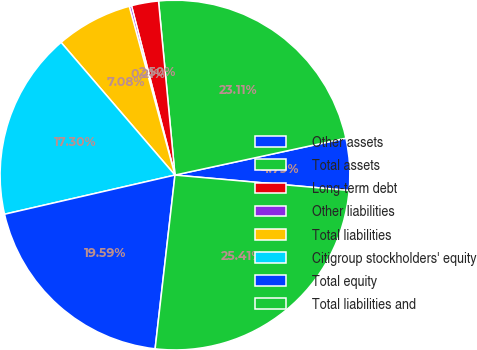<chart> <loc_0><loc_0><loc_500><loc_500><pie_chart><fcel>Other assets<fcel>Total assets<fcel>Long-term debt<fcel>Other liabilities<fcel>Total liabilities<fcel>Citigroup stockholders' equity<fcel>Total equity<fcel>Total liabilities and<nl><fcel>4.79%<fcel>23.11%<fcel>2.5%<fcel>0.21%<fcel>7.08%<fcel>17.3%<fcel>19.59%<fcel>25.4%<nl></chart> 